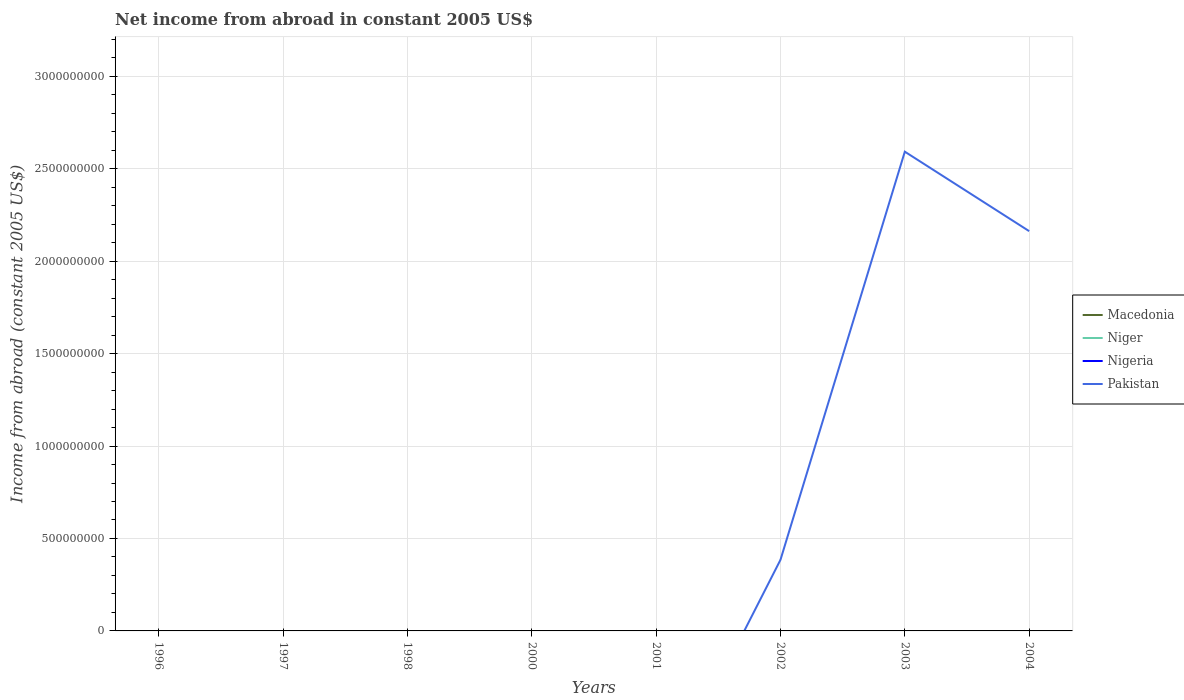How many different coloured lines are there?
Offer a terse response. 1. What is the difference between the highest and the second highest net income from abroad in Pakistan?
Keep it short and to the point. 2.59e+09. What is the difference between the highest and the lowest net income from abroad in Nigeria?
Offer a terse response. 0. How many lines are there?
Your answer should be compact. 1. Are the values on the major ticks of Y-axis written in scientific E-notation?
Offer a terse response. No. How many legend labels are there?
Keep it short and to the point. 4. How are the legend labels stacked?
Offer a terse response. Vertical. What is the title of the graph?
Your response must be concise. Net income from abroad in constant 2005 US$. What is the label or title of the Y-axis?
Provide a succinct answer. Income from abroad (constant 2005 US$). What is the Income from abroad (constant 2005 US$) in Niger in 1996?
Offer a terse response. 0. What is the Income from abroad (constant 2005 US$) of Nigeria in 1996?
Ensure brevity in your answer.  0. What is the Income from abroad (constant 2005 US$) of Pakistan in 1996?
Make the answer very short. 0. What is the Income from abroad (constant 2005 US$) of Nigeria in 1998?
Keep it short and to the point. 0. What is the Income from abroad (constant 2005 US$) in Pakistan in 1998?
Give a very brief answer. 0. What is the Income from abroad (constant 2005 US$) of Macedonia in 2000?
Ensure brevity in your answer.  0. What is the Income from abroad (constant 2005 US$) in Macedonia in 2001?
Give a very brief answer. 0. What is the Income from abroad (constant 2005 US$) of Niger in 2001?
Ensure brevity in your answer.  0. What is the Income from abroad (constant 2005 US$) in Nigeria in 2001?
Offer a terse response. 0. What is the Income from abroad (constant 2005 US$) of Pakistan in 2001?
Give a very brief answer. 0. What is the Income from abroad (constant 2005 US$) of Niger in 2002?
Provide a succinct answer. 0. What is the Income from abroad (constant 2005 US$) of Pakistan in 2002?
Make the answer very short. 3.84e+08. What is the Income from abroad (constant 2005 US$) of Pakistan in 2003?
Offer a terse response. 2.59e+09. What is the Income from abroad (constant 2005 US$) of Macedonia in 2004?
Provide a short and direct response. 0. What is the Income from abroad (constant 2005 US$) in Niger in 2004?
Your response must be concise. 0. What is the Income from abroad (constant 2005 US$) of Pakistan in 2004?
Provide a succinct answer. 2.16e+09. Across all years, what is the maximum Income from abroad (constant 2005 US$) of Pakistan?
Give a very brief answer. 2.59e+09. Across all years, what is the minimum Income from abroad (constant 2005 US$) of Pakistan?
Your response must be concise. 0. What is the total Income from abroad (constant 2005 US$) of Macedonia in the graph?
Offer a terse response. 0. What is the total Income from abroad (constant 2005 US$) in Niger in the graph?
Make the answer very short. 0. What is the total Income from abroad (constant 2005 US$) of Pakistan in the graph?
Give a very brief answer. 5.14e+09. What is the difference between the Income from abroad (constant 2005 US$) of Pakistan in 2002 and that in 2003?
Offer a very short reply. -2.21e+09. What is the difference between the Income from abroad (constant 2005 US$) of Pakistan in 2002 and that in 2004?
Make the answer very short. -1.78e+09. What is the difference between the Income from abroad (constant 2005 US$) of Pakistan in 2003 and that in 2004?
Make the answer very short. 4.30e+08. What is the average Income from abroad (constant 2005 US$) in Macedonia per year?
Make the answer very short. 0. What is the average Income from abroad (constant 2005 US$) of Niger per year?
Provide a short and direct response. 0. What is the average Income from abroad (constant 2005 US$) in Nigeria per year?
Offer a very short reply. 0. What is the average Income from abroad (constant 2005 US$) in Pakistan per year?
Provide a short and direct response. 6.42e+08. What is the ratio of the Income from abroad (constant 2005 US$) in Pakistan in 2002 to that in 2003?
Make the answer very short. 0.15. What is the ratio of the Income from abroad (constant 2005 US$) of Pakistan in 2002 to that in 2004?
Offer a terse response. 0.18. What is the ratio of the Income from abroad (constant 2005 US$) of Pakistan in 2003 to that in 2004?
Make the answer very short. 1.2. What is the difference between the highest and the second highest Income from abroad (constant 2005 US$) of Pakistan?
Provide a short and direct response. 4.30e+08. What is the difference between the highest and the lowest Income from abroad (constant 2005 US$) of Pakistan?
Provide a succinct answer. 2.59e+09. 